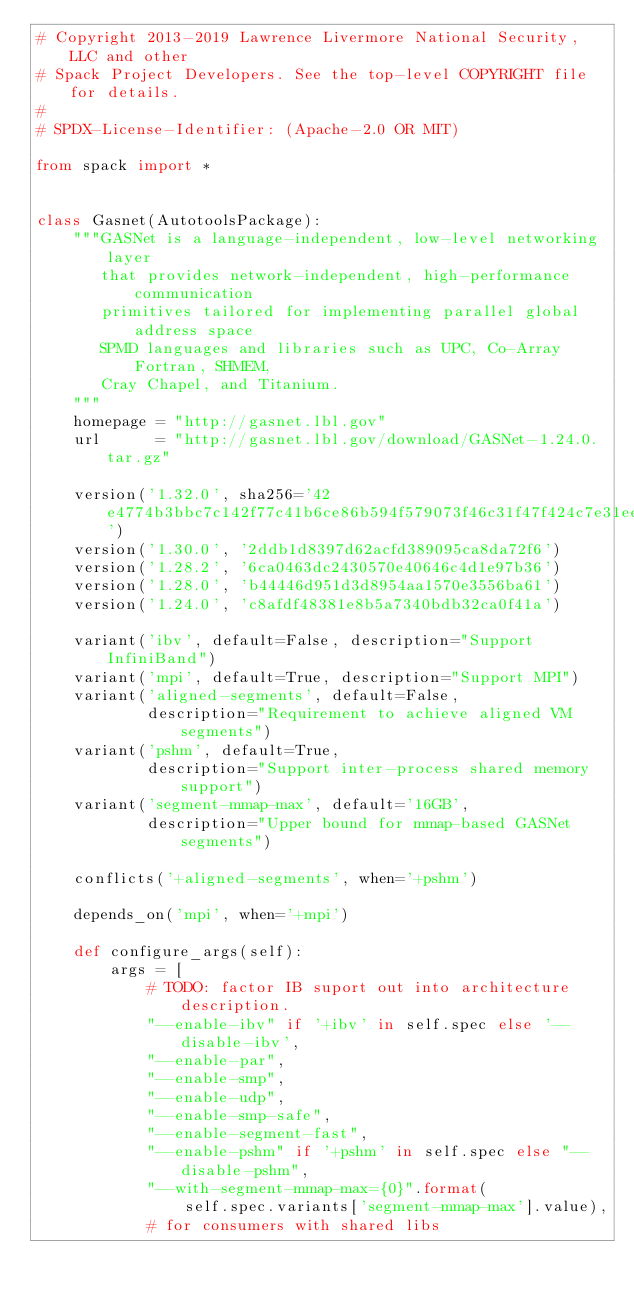<code> <loc_0><loc_0><loc_500><loc_500><_Python_># Copyright 2013-2019 Lawrence Livermore National Security, LLC and other
# Spack Project Developers. See the top-level COPYRIGHT file for details.
#
# SPDX-License-Identifier: (Apache-2.0 OR MIT)

from spack import *


class Gasnet(AutotoolsPackage):
    """GASNet is a language-independent, low-level networking layer
       that provides network-independent, high-performance communication
       primitives tailored for implementing parallel global address space
       SPMD languages and libraries such as UPC, Co-Array Fortran, SHMEM,
       Cray Chapel, and Titanium.
    """
    homepage = "http://gasnet.lbl.gov"
    url      = "http://gasnet.lbl.gov/download/GASNet-1.24.0.tar.gz"

    version('1.32.0', sha256='42e4774b3bbc7c142f77c41b6ce86b594f579073f46c31f47f424c7e31ee1511')
    version('1.30.0', '2ddb1d8397d62acfd389095ca8da72f6')
    version('1.28.2', '6ca0463dc2430570e40646c4d1e97b36')
    version('1.28.0', 'b44446d951d3d8954aa1570e3556ba61')
    version('1.24.0', 'c8afdf48381e8b5a7340bdb32ca0f41a')

    variant('ibv', default=False, description="Support InfiniBand")
    variant('mpi', default=True, description="Support MPI")
    variant('aligned-segments', default=False,
            description="Requirement to achieve aligned VM segments")
    variant('pshm', default=True, 
            description="Support inter-process shared memory support")
    variant('segment-mmap-max', default='16GB',
            description="Upper bound for mmap-based GASNet segments")

    conflicts('+aligned-segments', when='+pshm')

    depends_on('mpi', when='+mpi')

    def configure_args(self):
        args = [
            # TODO: factor IB suport out into architecture description.
            "--enable-ibv" if '+ibv' in self.spec else '--disable-ibv',
            "--enable-par",
            "--enable-smp",
            "--enable-udp",
            "--enable-smp-safe",
            "--enable-segment-fast",
            "--enable-pshm" if '+pshm' in self.spec else "--disable-pshm",
            "--with-segment-mmap-max={0}".format(
                self.spec.variants['segment-mmap-max'].value),
            # for consumers with shared libs</code> 